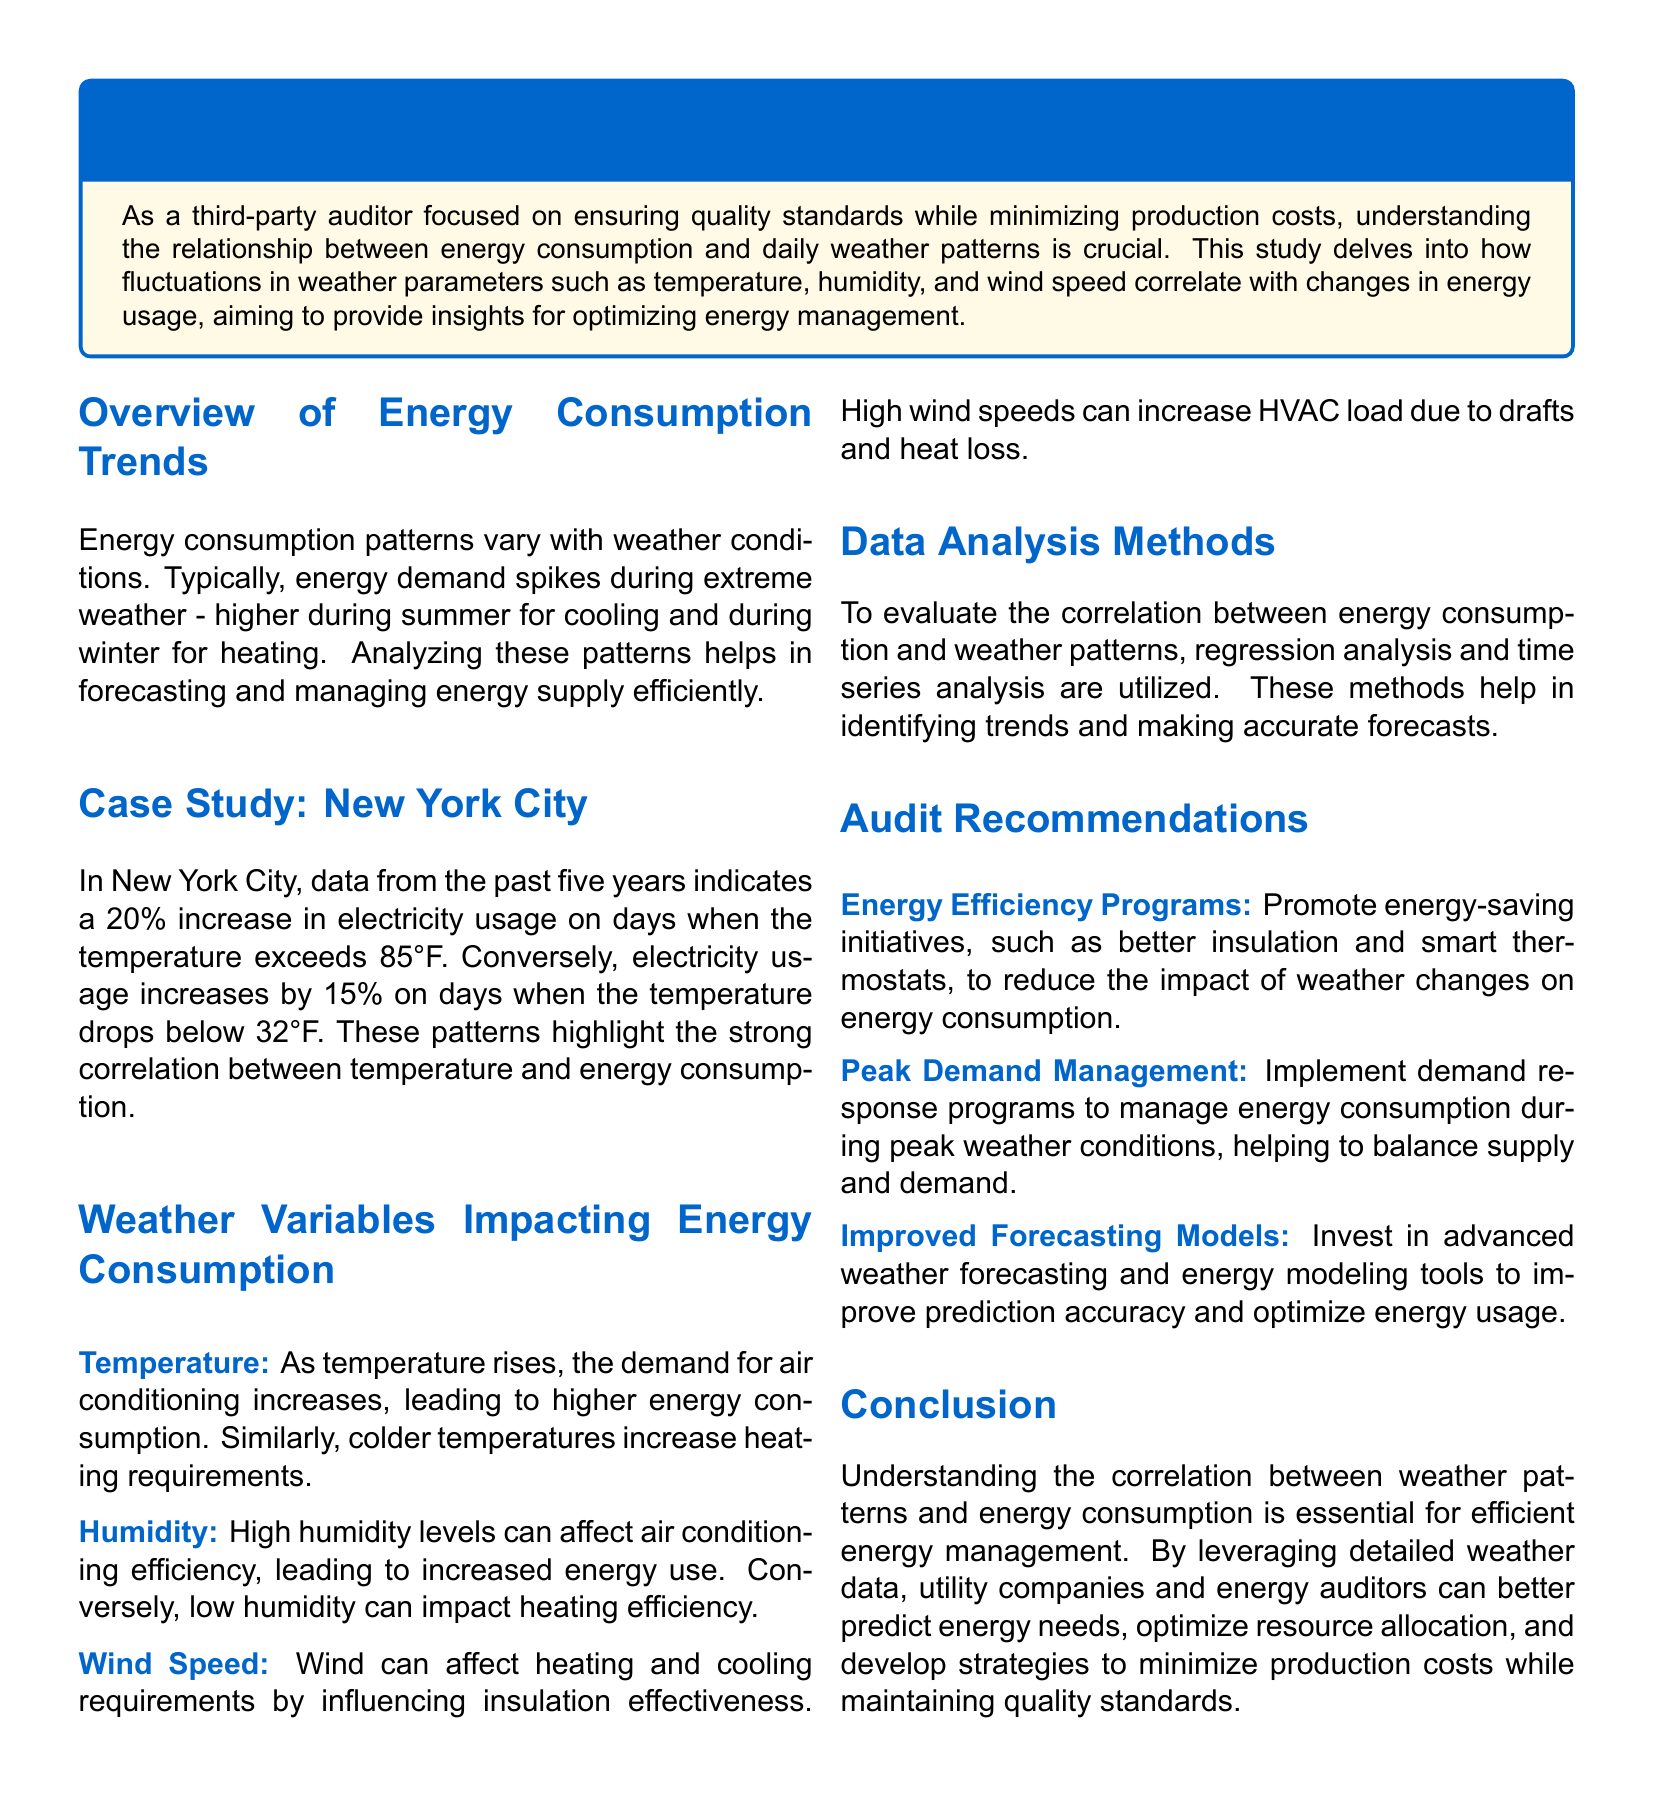What is the main focus of the study? The study focuses on understanding the relationship between energy consumption and daily weather patterns.
Answer: relationship between energy consumption and daily weather patterns What percentage increase in electricity usage occurs in New York City when temperatures exceed 85°F? The document states a 20% increase in electricity usage on days when the temperature exceeds 85°F.
Answer: 20% What weather variable affects air conditioning efficiency? The document mentions humidity as a weather variable that affects air conditioning efficiency.
Answer: humidity What data analysis methods are utilized to evaluate the correlation? The document states that regression analysis and time series analysis are utilized to evaluate the correlation.
Answer: regression analysis and time series analysis What recommendation is made to promote energy efficiency? The document suggests promoting energy-saving initiatives, such as better insulation and smart thermostats, to reduce energy consumption impact.
Answer: better insulation and smart thermostats What is the percentage increase in electricity usage when temperatures drop below 32°F in New York City? According to the document, there is a 15% increase in electricity usage when temperatures drop below 32°F.
Answer: 15% What is the primary goal of understanding weather patterns in energy management? The document emphasizes that understanding these correlations is essential for efficient energy management.
Answer: efficient energy management Which case study is mentioned in the document? The case study mentioned in the document is New York City.
Answer: New York City 